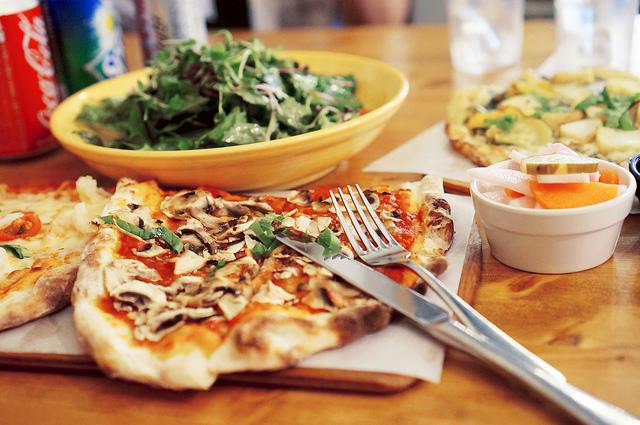What silverware is in the picture?
Concise answer only. Fork and knife. What brand of soda is the silver can?
Keep it brief. Diet coke. What kind of crust is on the pizza?
Short answer required. Thin. Is this Italian?
Be succinct. Yes. 